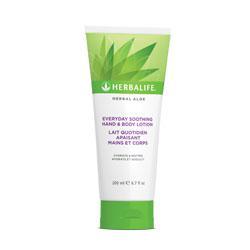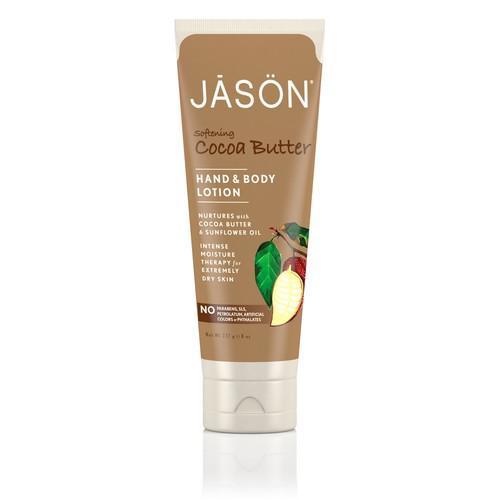The first image is the image on the left, the second image is the image on the right. Assess this claim about the two images: "At least one bottle of body lotion has a pump top.". Correct or not? Answer yes or no. No. The first image is the image on the left, the second image is the image on the right. Examine the images to the left and right. Is the description "Each image contains one skincare product on white background." accurate? Answer yes or no. Yes. 